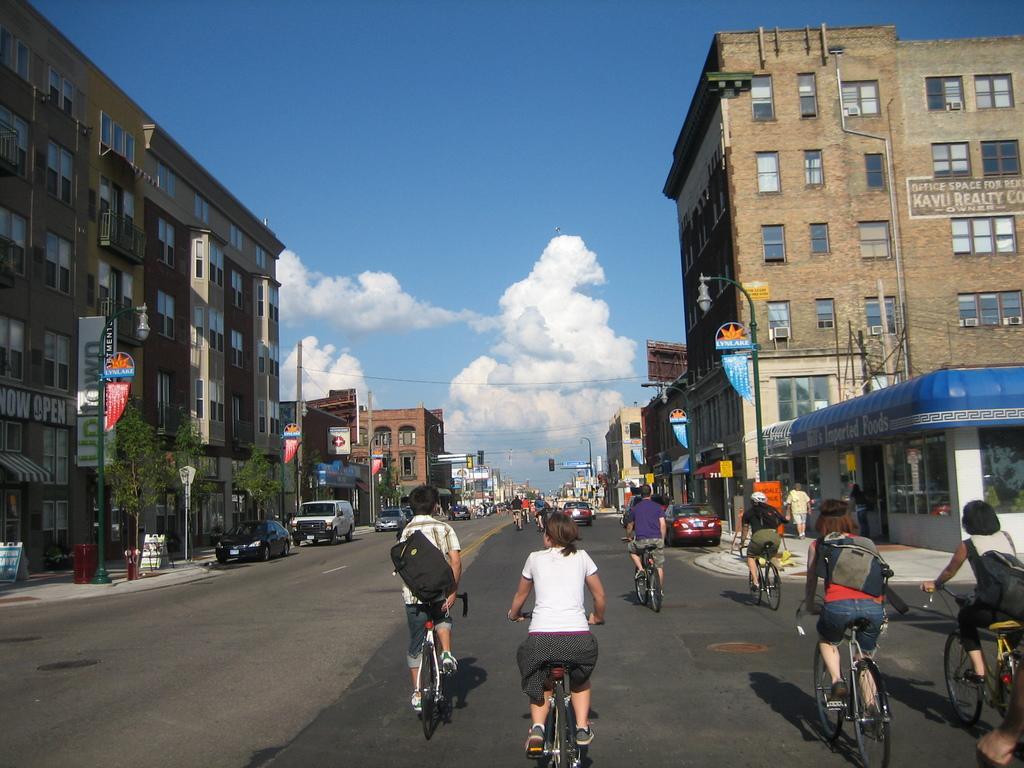Please provide a concise description of this image. In this image I see buildings, light poles and I see the road on which there are cars and I see few people on cycles and I see few trees. In the background I see the sky which is clear and I see a board over here on which something is written. 